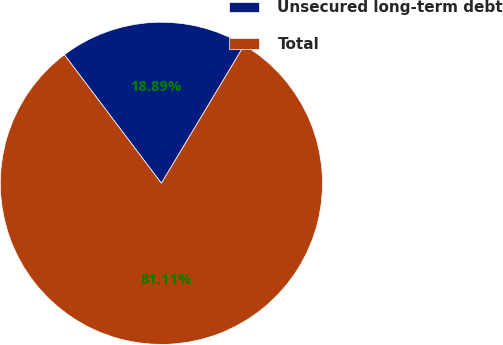<chart> <loc_0><loc_0><loc_500><loc_500><pie_chart><fcel>Unsecured long-term debt<fcel>Total<nl><fcel>18.89%<fcel>81.11%<nl></chart> 